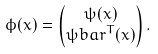Convert formula to latex. <formula><loc_0><loc_0><loc_500><loc_500>\phi ( x ) & = \begin{pmatrix} \psi ( x ) \\ \psi b a r ^ { T } ( x ) \end{pmatrix} .</formula> 